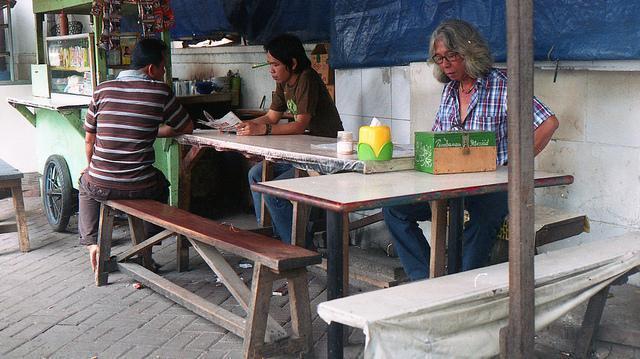How many benches are visible?
Give a very brief answer. 2. How many dining tables are in the photo?
Give a very brief answer. 2. How many people are in the picture?
Give a very brief answer. 3. How many cars do you see?
Give a very brief answer. 0. 